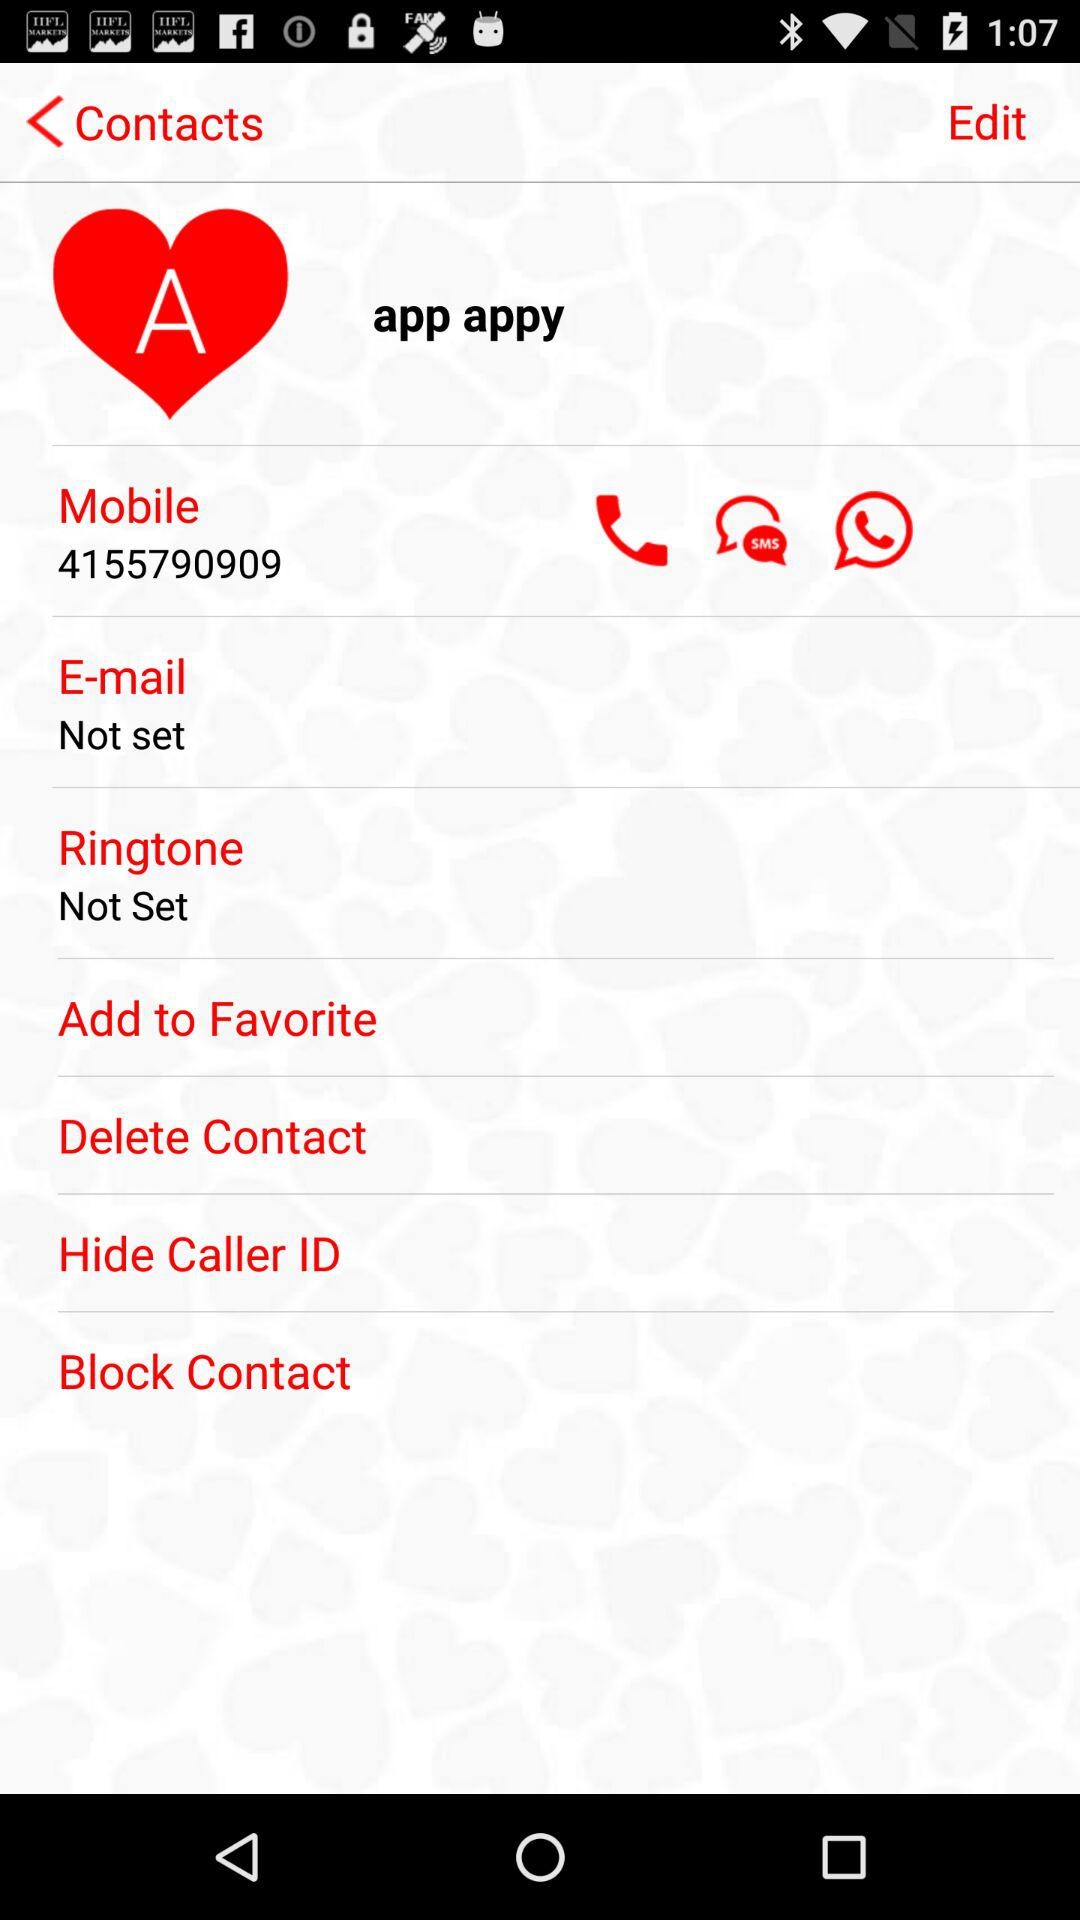What is the name of the contact? The name is "app appy". 